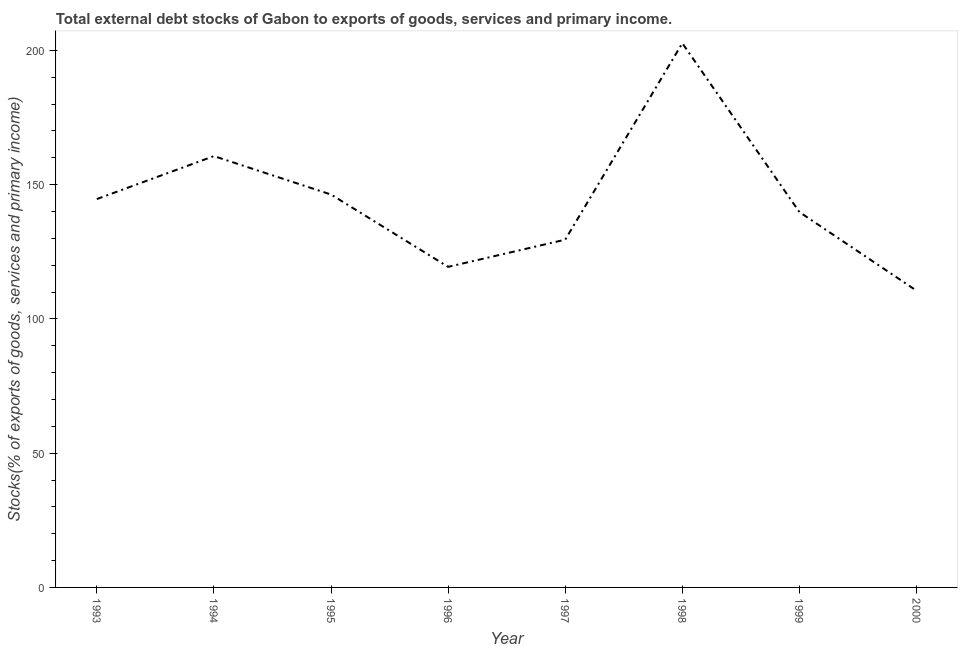What is the external debt stocks in 1998?
Your answer should be very brief. 202.7. Across all years, what is the maximum external debt stocks?
Give a very brief answer. 202.7. Across all years, what is the minimum external debt stocks?
Provide a succinct answer. 110.52. What is the sum of the external debt stocks?
Ensure brevity in your answer.  1153.59. What is the difference between the external debt stocks in 1993 and 1996?
Your answer should be very brief. 25.25. What is the average external debt stocks per year?
Provide a short and direct response. 144.2. What is the median external debt stocks?
Offer a very short reply. 142.23. Do a majority of the years between 1998 and 1997 (inclusive) have external debt stocks greater than 120 %?
Provide a succinct answer. No. What is the ratio of the external debt stocks in 1998 to that in 2000?
Your answer should be very brief. 1.83. Is the external debt stocks in 1995 less than that in 1997?
Your answer should be compact. No. Is the difference between the external debt stocks in 1994 and 1995 greater than the difference between any two years?
Your answer should be very brief. No. What is the difference between the highest and the second highest external debt stocks?
Your answer should be very brief. 42.05. What is the difference between the highest and the lowest external debt stocks?
Make the answer very short. 92.18. Does the external debt stocks monotonically increase over the years?
Ensure brevity in your answer.  No. How many lines are there?
Offer a terse response. 1. What is the difference between two consecutive major ticks on the Y-axis?
Keep it short and to the point. 50. Are the values on the major ticks of Y-axis written in scientific E-notation?
Offer a very short reply. No. What is the title of the graph?
Keep it short and to the point. Total external debt stocks of Gabon to exports of goods, services and primary income. What is the label or title of the X-axis?
Ensure brevity in your answer.  Year. What is the label or title of the Y-axis?
Provide a succinct answer. Stocks(% of exports of goods, services and primary income). What is the Stocks(% of exports of goods, services and primary income) of 1993?
Your answer should be compact. 144.65. What is the Stocks(% of exports of goods, services and primary income) in 1994?
Give a very brief answer. 160.65. What is the Stocks(% of exports of goods, services and primary income) of 1995?
Make the answer very short. 146.34. What is the Stocks(% of exports of goods, services and primary income) of 1996?
Your response must be concise. 119.4. What is the Stocks(% of exports of goods, services and primary income) of 1997?
Provide a succinct answer. 129.52. What is the Stocks(% of exports of goods, services and primary income) in 1998?
Your answer should be compact. 202.7. What is the Stocks(% of exports of goods, services and primary income) in 1999?
Your answer should be very brief. 139.81. What is the Stocks(% of exports of goods, services and primary income) of 2000?
Ensure brevity in your answer.  110.52. What is the difference between the Stocks(% of exports of goods, services and primary income) in 1993 and 1994?
Provide a succinct answer. -16. What is the difference between the Stocks(% of exports of goods, services and primary income) in 1993 and 1995?
Ensure brevity in your answer.  -1.69. What is the difference between the Stocks(% of exports of goods, services and primary income) in 1993 and 1996?
Offer a terse response. 25.25. What is the difference between the Stocks(% of exports of goods, services and primary income) in 1993 and 1997?
Your response must be concise. 15.13. What is the difference between the Stocks(% of exports of goods, services and primary income) in 1993 and 1998?
Your response must be concise. -58.05. What is the difference between the Stocks(% of exports of goods, services and primary income) in 1993 and 1999?
Provide a short and direct response. 4.84. What is the difference between the Stocks(% of exports of goods, services and primary income) in 1993 and 2000?
Provide a succinct answer. 34.13. What is the difference between the Stocks(% of exports of goods, services and primary income) in 1994 and 1995?
Keep it short and to the point. 14.31. What is the difference between the Stocks(% of exports of goods, services and primary income) in 1994 and 1996?
Provide a short and direct response. 41.25. What is the difference between the Stocks(% of exports of goods, services and primary income) in 1994 and 1997?
Provide a short and direct response. 31.13. What is the difference between the Stocks(% of exports of goods, services and primary income) in 1994 and 1998?
Your answer should be very brief. -42.05. What is the difference between the Stocks(% of exports of goods, services and primary income) in 1994 and 1999?
Ensure brevity in your answer.  20.84. What is the difference between the Stocks(% of exports of goods, services and primary income) in 1994 and 2000?
Your answer should be very brief. 50.13. What is the difference between the Stocks(% of exports of goods, services and primary income) in 1995 and 1996?
Make the answer very short. 26.94. What is the difference between the Stocks(% of exports of goods, services and primary income) in 1995 and 1997?
Make the answer very short. 16.82. What is the difference between the Stocks(% of exports of goods, services and primary income) in 1995 and 1998?
Keep it short and to the point. -56.36. What is the difference between the Stocks(% of exports of goods, services and primary income) in 1995 and 1999?
Provide a short and direct response. 6.53. What is the difference between the Stocks(% of exports of goods, services and primary income) in 1995 and 2000?
Provide a succinct answer. 35.81. What is the difference between the Stocks(% of exports of goods, services and primary income) in 1996 and 1997?
Make the answer very short. -10.12. What is the difference between the Stocks(% of exports of goods, services and primary income) in 1996 and 1998?
Your answer should be very brief. -83.3. What is the difference between the Stocks(% of exports of goods, services and primary income) in 1996 and 1999?
Offer a very short reply. -20.41. What is the difference between the Stocks(% of exports of goods, services and primary income) in 1996 and 2000?
Offer a terse response. 8.88. What is the difference between the Stocks(% of exports of goods, services and primary income) in 1997 and 1998?
Make the answer very short. -73.18. What is the difference between the Stocks(% of exports of goods, services and primary income) in 1997 and 1999?
Your answer should be very brief. -10.29. What is the difference between the Stocks(% of exports of goods, services and primary income) in 1997 and 2000?
Your answer should be very brief. 19. What is the difference between the Stocks(% of exports of goods, services and primary income) in 1998 and 1999?
Keep it short and to the point. 62.89. What is the difference between the Stocks(% of exports of goods, services and primary income) in 1998 and 2000?
Your response must be concise. 92.18. What is the difference between the Stocks(% of exports of goods, services and primary income) in 1999 and 2000?
Your answer should be compact. 29.28. What is the ratio of the Stocks(% of exports of goods, services and primary income) in 1993 to that in 1994?
Your response must be concise. 0.9. What is the ratio of the Stocks(% of exports of goods, services and primary income) in 1993 to that in 1995?
Offer a terse response. 0.99. What is the ratio of the Stocks(% of exports of goods, services and primary income) in 1993 to that in 1996?
Offer a terse response. 1.21. What is the ratio of the Stocks(% of exports of goods, services and primary income) in 1993 to that in 1997?
Your answer should be compact. 1.12. What is the ratio of the Stocks(% of exports of goods, services and primary income) in 1993 to that in 1998?
Your answer should be very brief. 0.71. What is the ratio of the Stocks(% of exports of goods, services and primary income) in 1993 to that in 1999?
Provide a short and direct response. 1.03. What is the ratio of the Stocks(% of exports of goods, services and primary income) in 1993 to that in 2000?
Give a very brief answer. 1.31. What is the ratio of the Stocks(% of exports of goods, services and primary income) in 1994 to that in 1995?
Your response must be concise. 1.1. What is the ratio of the Stocks(% of exports of goods, services and primary income) in 1994 to that in 1996?
Give a very brief answer. 1.34. What is the ratio of the Stocks(% of exports of goods, services and primary income) in 1994 to that in 1997?
Your response must be concise. 1.24. What is the ratio of the Stocks(% of exports of goods, services and primary income) in 1994 to that in 1998?
Give a very brief answer. 0.79. What is the ratio of the Stocks(% of exports of goods, services and primary income) in 1994 to that in 1999?
Give a very brief answer. 1.15. What is the ratio of the Stocks(% of exports of goods, services and primary income) in 1994 to that in 2000?
Your answer should be very brief. 1.45. What is the ratio of the Stocks(% of exports of goods, services and primary income) in 1995 to that in 1996?
Offer a very short reply. 1.23. What is the ratio of the Stocks(% of exports of goods, services and primary income) in 1995 to that in 1997?
Give a very brief answer. 1.13. What is the ratio of the Stocks(% of exports of goods, services and primary income) in 1995 to that in 1998?
Provide a succinct answer. 0.72. What is the ratio of the Stocks(% of exports of goods, services and primary income) in 1995 to that in 1999?
Offer a very short reply. 1.05. What is the ratio of the Stocks(% of exports of goods, services and primary income) in 1995 to that in 2000?
Your answer should be very brief. 1.32. What is the ratio of the Stocks(% of exports of goods, services and primary income) in 1996 to that in 1997?
Provide a short and direct response. 0.92. What is the ratio of the Stocks(% of exports of goods, services and primary income) in 1996 to that in 1998?
Provide a succinct answer. 0.59. What is the ratio of the Stocks(% of exports of goods, services and primary income) in 1996 to that in 1999?
Make the answer very short. 0.85. What is the ratio of the Stocks(% of exports of goods, services and primary income) in 1996 to that in 2000?
Offer a very short reply. 1.08. What is the ratio of the Stocks(% of exports of goods, services and primary income) in 1997 to that in 1998?
Your answer should be very brief. 0.64. What is the ratio of the Stocks(% of exports of goods, services and primary income) in 1997 to that in 1999?
Make the answer very short. 0.93. What is the ratio of the Stocks(% of exports of goods, services and primary income) in 1997 to that in 2000?
Provide a short and direct response. 1.17. What is the ratio of the Stocks(% of exports of goods, services and primary income) in 1998 to that in 1999?
Keep it short and to the point. 1.45. What is the ratio of the Stocks(% of exports of goods, services and primary income) in 1998 to that in 2000?
Provide a short and direct response. 1.83. What is the ratio of the Stocks(% of exports of goods, services and primary income) in 1999 to that in 2000?
Offer a very short reply. 1.26. 